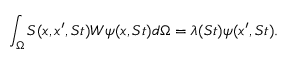Convert formula to latex. <formula><loc_0><loc_0><loc_500><loc_500>\int _ { \Omega } S ( x , x ^ { \prime } , S t ) W \psi ( x , S t ) d \Omega = \lambda ( S t ) \psi ( x ^ { \prime } , S t ) .</formula> 